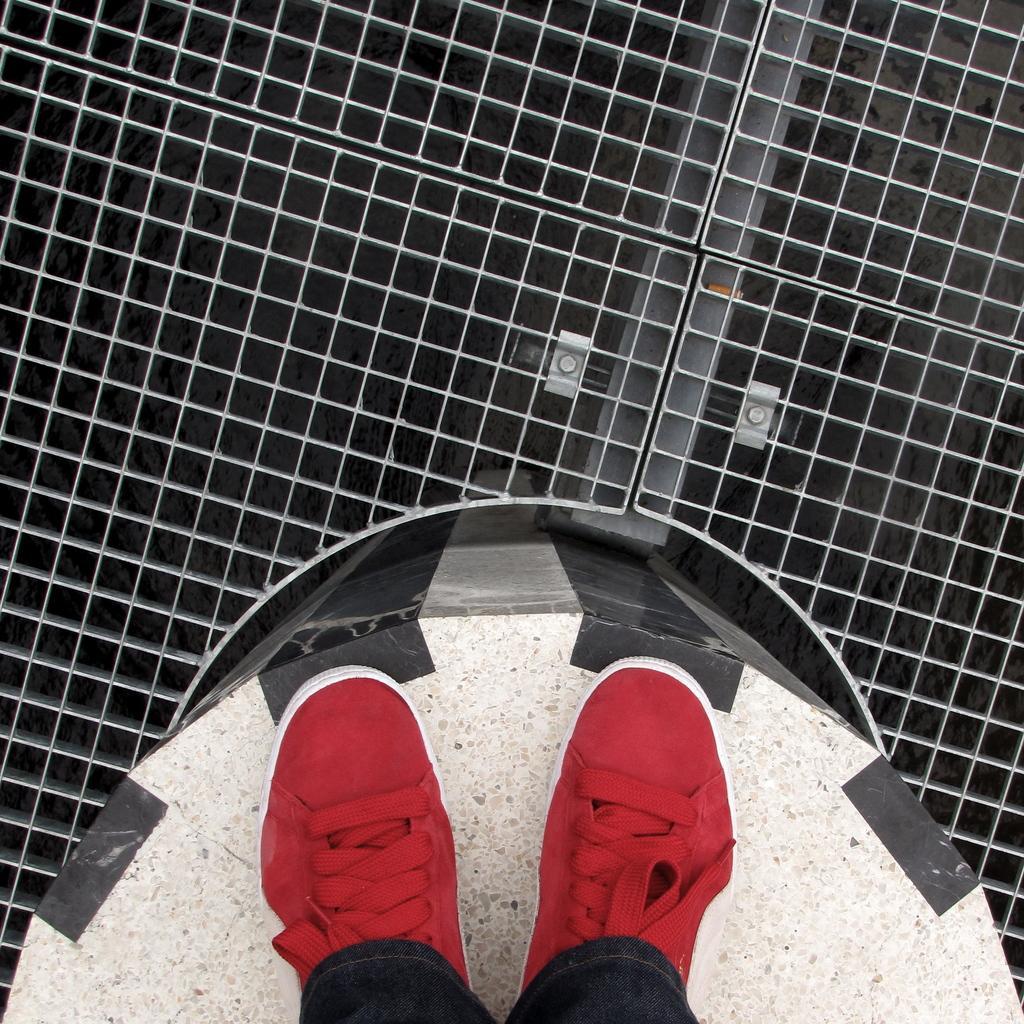Could you give a brief overview of what you see in this image? In this image at the bottom there is one person who is standing on some wall, and on the top of the image there is a gate. 